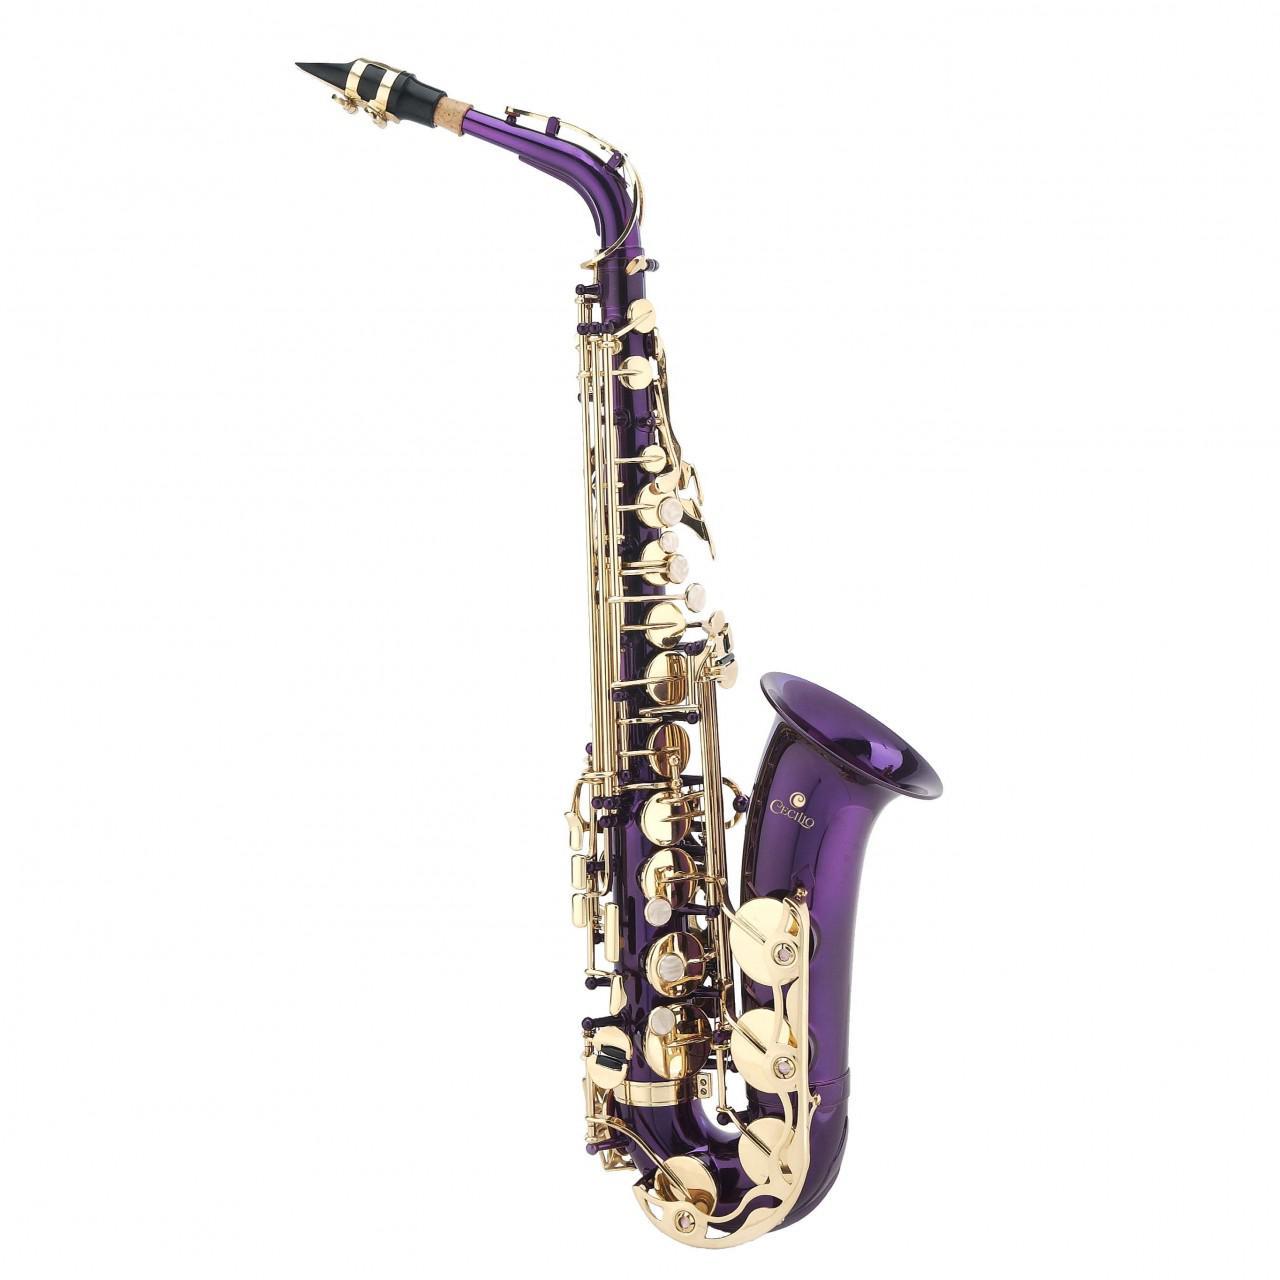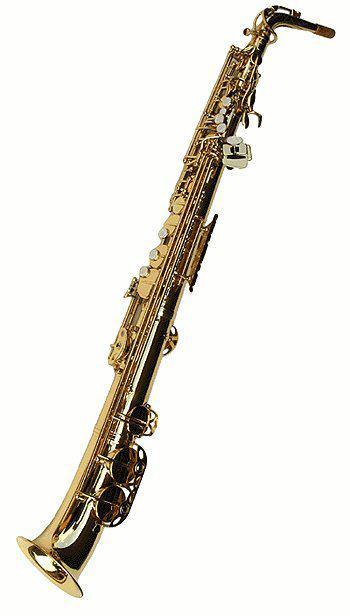The first image is the image on the left, the second image is the image on the right. For the images displayed, is the sentence "The left image contains one purple and gold saxophone." factually correct? Answer yes or no. Yes. 